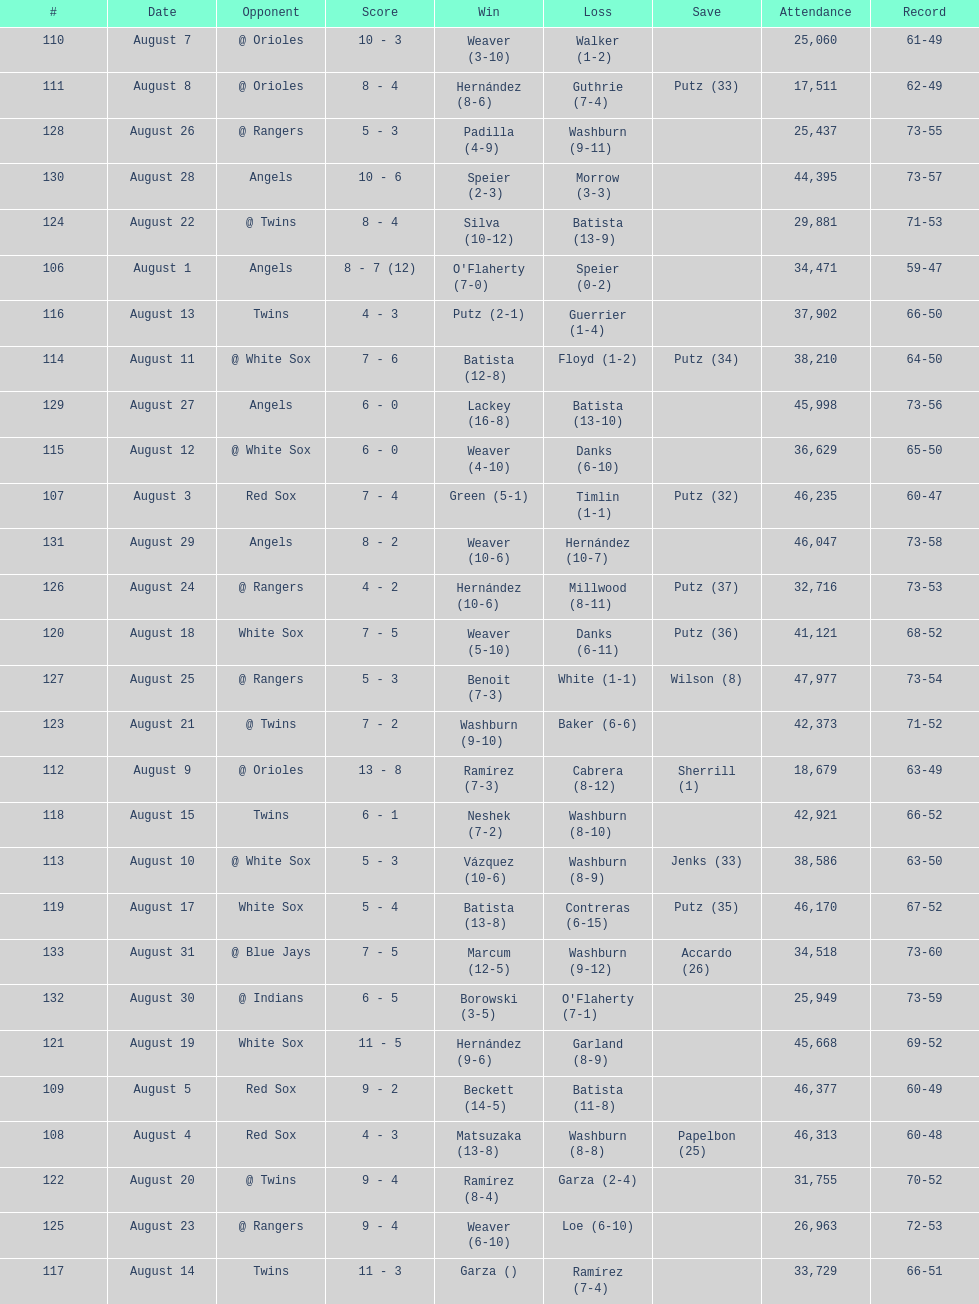What was the total number of games played in august 2007? 28. 